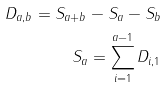<formula> <loc_0><loc_0><loc_500><loc_500>D _ { a , b } = S _ { a + b } - S _ { a } - S _ { b } \\ S _ { a } = \sum _ { i = 1 } ^ { a - 1 } D _ { i , 1 }</formula> 